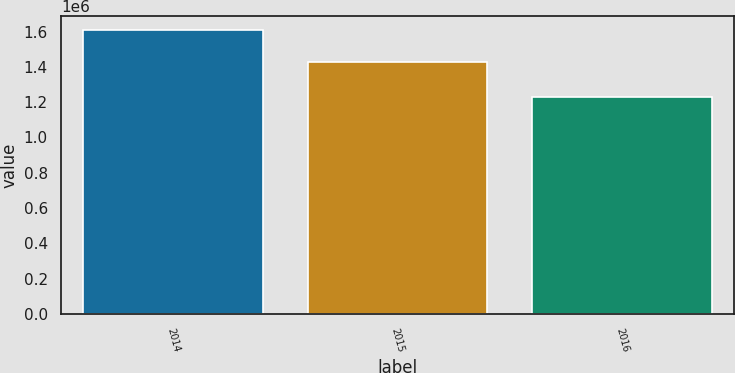<chart> <loc_0><loc_0><loc_500><loc_500><bar_chart><fcel>2014<fcel>2015<fcel>2016<nl><fcel>1.60928e+06<fcel>1.4258e+06<fcel>1.23215e+06<nl></chart> 